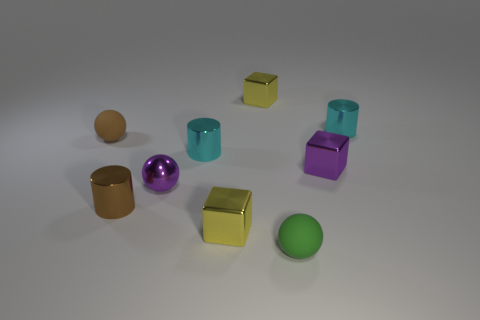Subtract all spheres. How many objects are left? 6 Subtract 3 balls. How many balls are left? 0 Subtract all brown cylinders. Subtract all gray cubes. How many cylinders are left? 2 Subtract all yellow cylinders. How many yellow spheres are left? 0 Subtract all tiny yellow blocks. Subtract all green things. How many objects are left? 6 Add 1 shiny blocks. How many shiny blocks are left? 4 Add 7 tiny matte things. How many tiny matte things exist? 9 Subtract all yellow cubes. How many cubes are left? 1 Subtract all tiny yellow shiny blocks. How many blocks are left? 1 Subtract 1 green spheres. How many objects are left? 8 